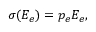<formula> <loc_0><loc_0><loc_500><loc_500>\sigma ( E _ { e } ) = p _ { e } E _ { e } ,</formula> 